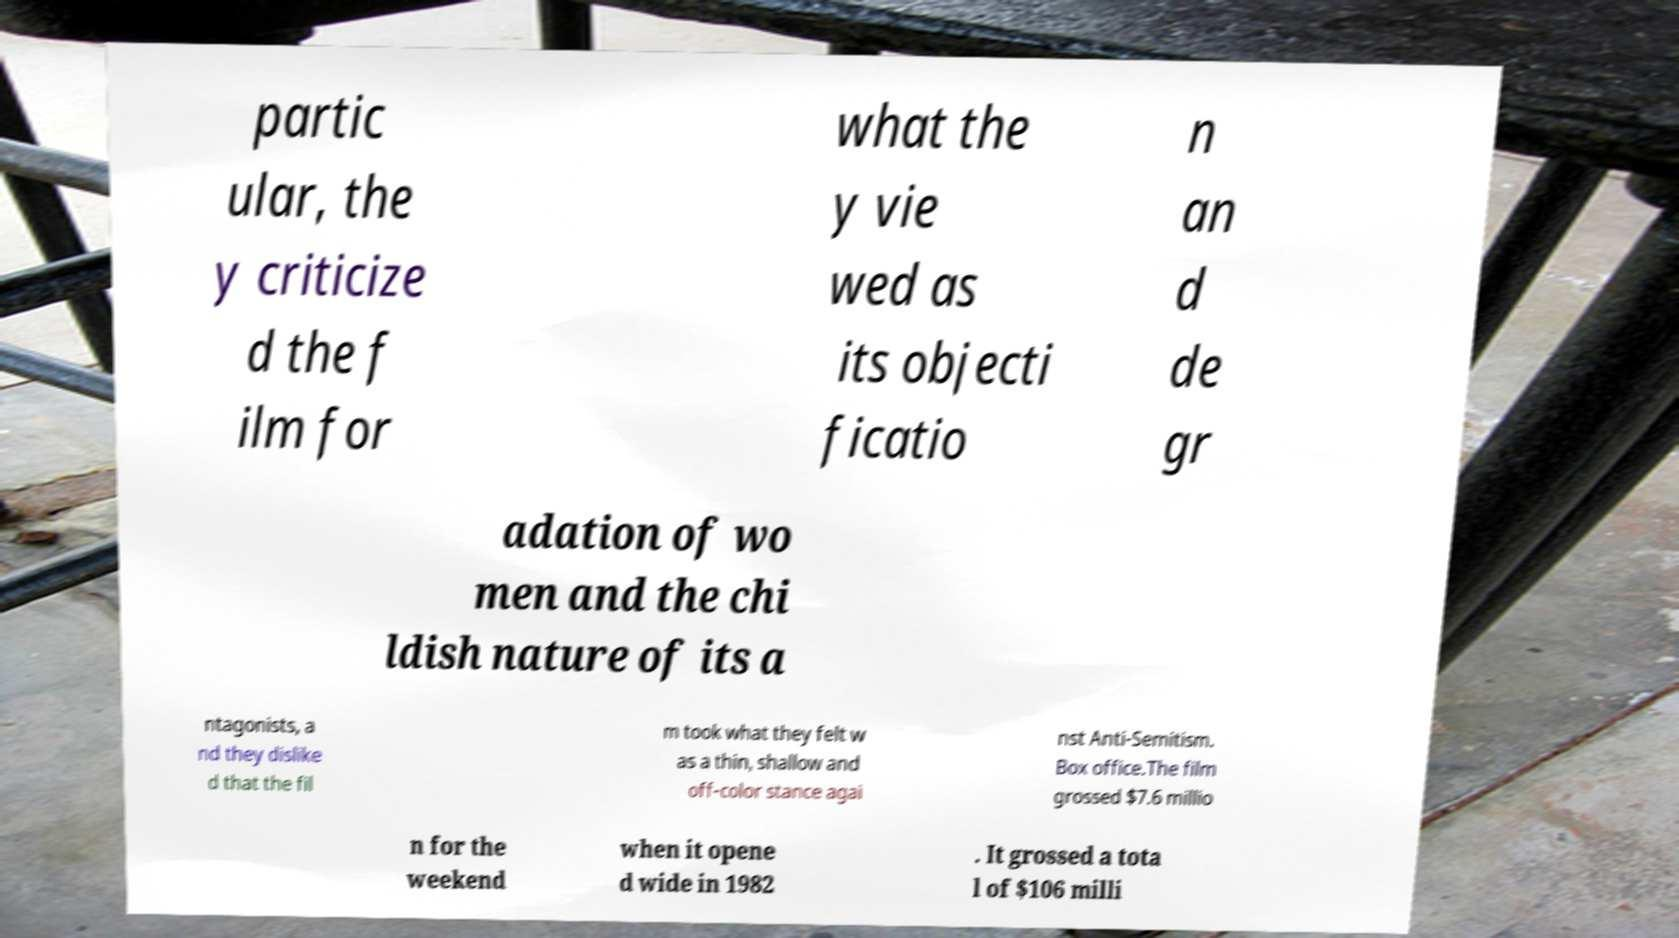For documentation purposes, I need the text within this image transcribed. Could you provide that? partic ular, the y criticize d the f ilm for what the y vie wed as its objecti ficatio n an d de gr adation of wo men and the chi ldish nature of its a ntagonists, a nd they dislike d that the fil m took what they felt w as a thin, shallow and off-color stance agai nst Anti-Semitism. Box office.The film grossed $7.6 millio n for the weekend when it opene d wide in 1982 . It grossed a tota l of $106 milli 